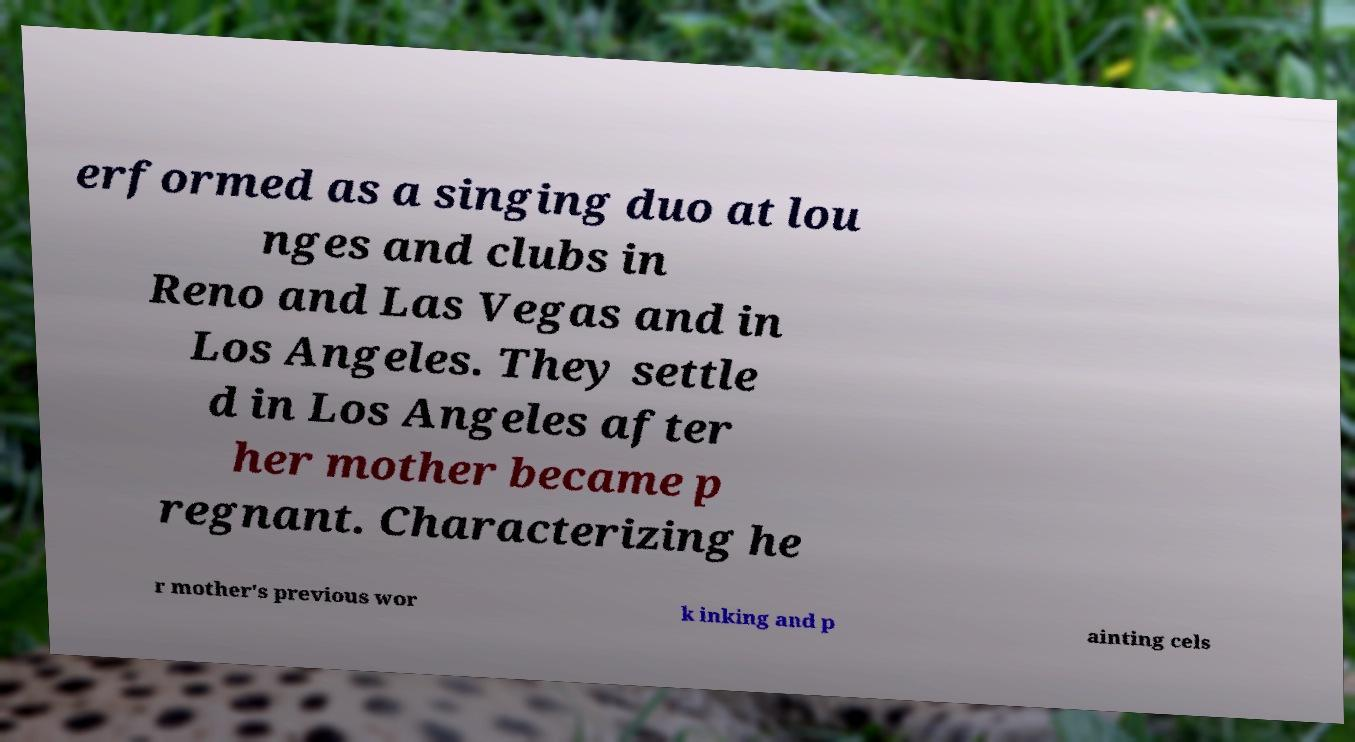Can you read and provide the text displayed in the image?This photo seems to have some interesting text. Can you extract and type it out for me? erformed as a singing duo at lou nges and clubs in Reno and Las Vegas and in Los Angeles. They settle d in Los Angeles after her mother became p regnant. Characterizing he r mother's previous wor k inking and p ainting cels 